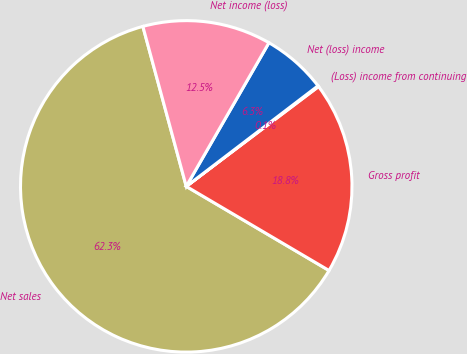Convert chart to OTSL. <chart><loc_0><loc_0><loc_500><loc_500><pie_chart><fcel>Net sales<fcel>Gross profit<fcel>(Loss) income from continuing<fcel>Net (loss) income<fcel>Net income (loss)<nl><fcel>62.31%<fcel>18.76%<fcel>0.09%<fcel>6.31%<fcel>12.53%<nl></chart> 